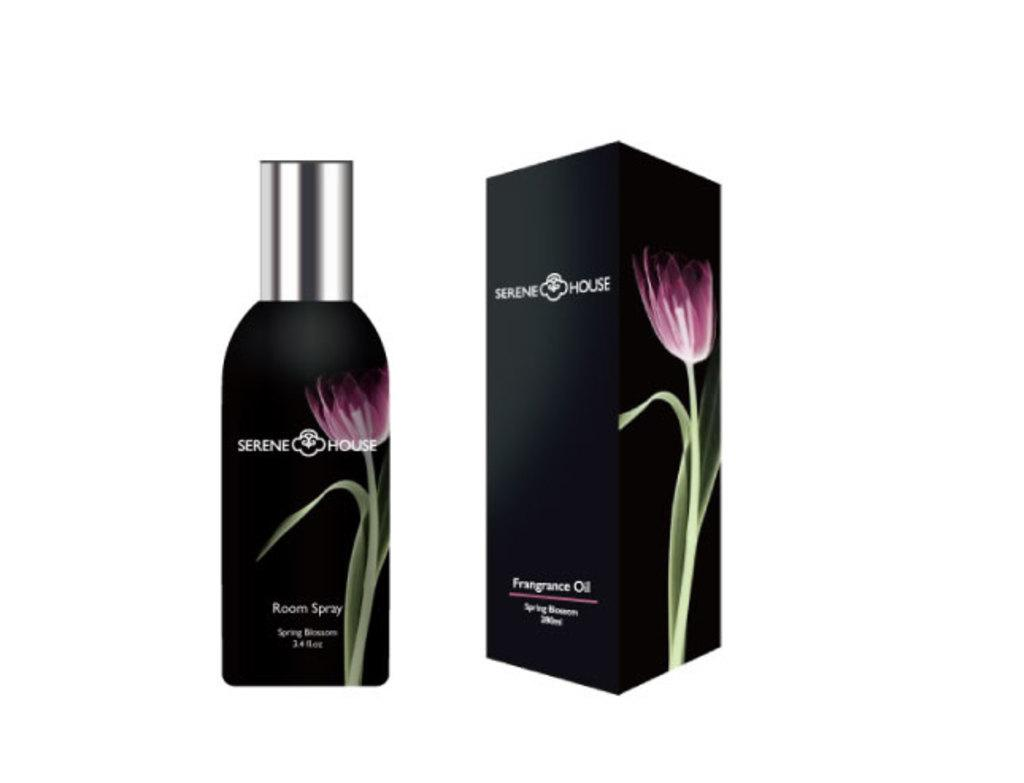<image>
Summarize the visual content of the image. A bottle of room spray by Serene House next to the box it comes in. 